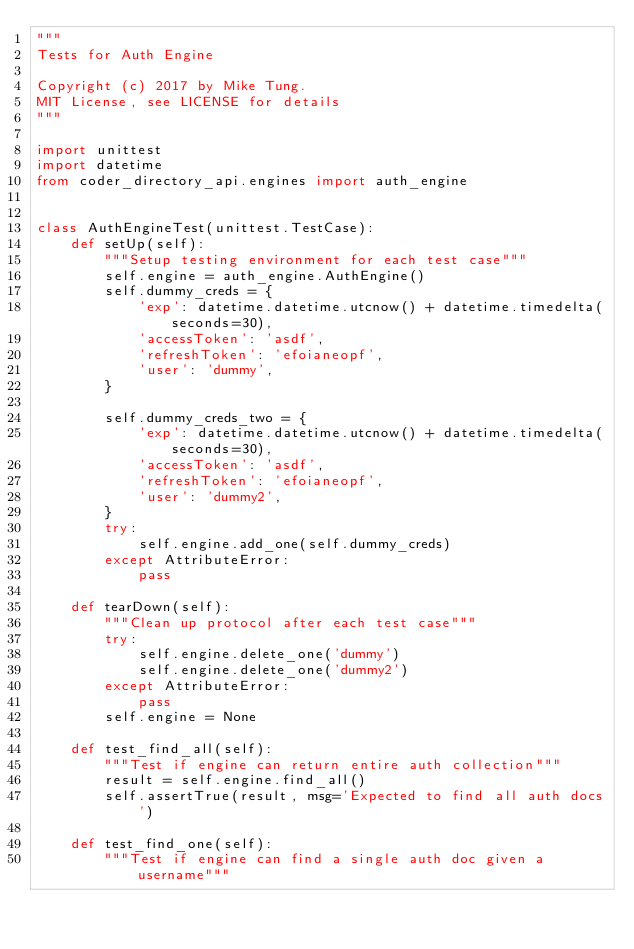<code> <loc_0><loc_0><loc_500><loc_500><_Python_>"""
Tests for Auth Engine

Copyright (c) 2017 by Mike Tung.
MIT License, see LICENSE for details
"""

import unittest
import datetime
from coder_directory_api.engines import auth_engine


class AuthEngineTest(unittest.TestCase):
    def setUp(self):
        """Setup testing environment for each test case"""
        self.engine = auth_engine.AuthEngine()
        self.dummy_creds = {
            'exp': datetime.datetime.utcnow() + datetime.timedelta(seconds=30),
            'accessToken': 'asdf',
            'refreshToken': 'efoianeopf',
            'user': 'dummy',
        }

        self.dummy_creds_two = {
            'exp': datetime.datetime.utcnow() + datetime.timedelta(seconds=30),
            'accessToken': 'asdf',
            'refreshToken': 'efoianeopf',
            'user': 'dummy2',
        }
        try:
            self.engine.add_one(self.dummy_creds)
        except AttributeError:
            pass

    def tearDown(self):
        """Clean up protocol after each test case"""
        try:
            self.engine.delete_one('dummy')
            self.engine.delete_one('dummy2')
        except AttributeError:
            pass
        self.engine = None

    def test_find_all(self):
        """Test if engine can return entire auth collection"""
        result = self.engine.find_all()
        self.assertTrue(result, msg='Expected to find all auth docs')

    def test_find_one(self):
        """Test if engine can find a single auth doc given a username"""</code> 